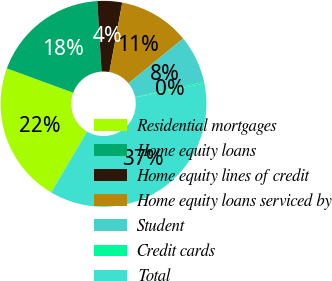Convert chart. <chart><loc_0><loc_0><loc_500><loc_500><pie_chart><fcel>Residential mortgages<fcel>Home equity loans<fcel>Home equity lines of credit<fcel>Home equity loans serviced by<fcel>Student<fcel>Credit cards<fcel>Total<nl><fcel>22.09%<fcel>18.45%<fcel>3.88%<fcel>11.16%<fcel>7.52%<fcel>0.24%<fcel>36.66%<nl></chart> 